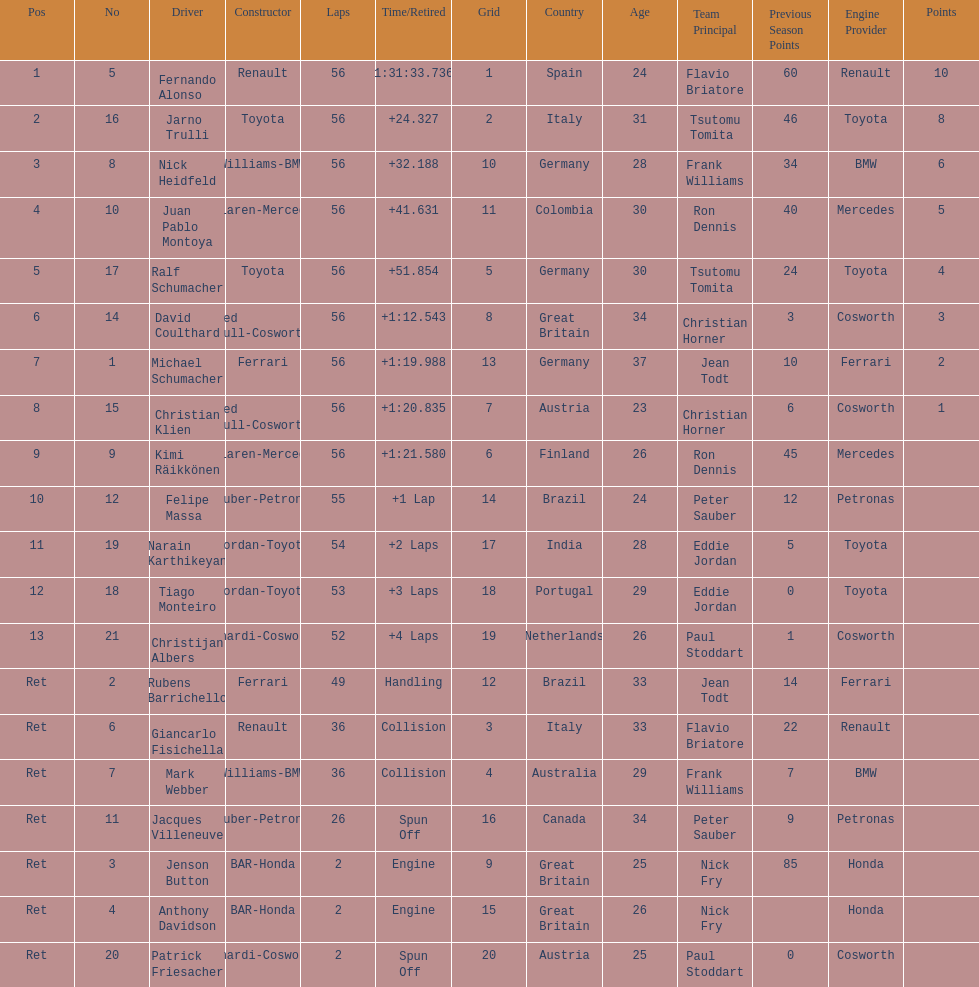Who was the last driver from the uk to actually finish the 56 laps? David Coulthard. 